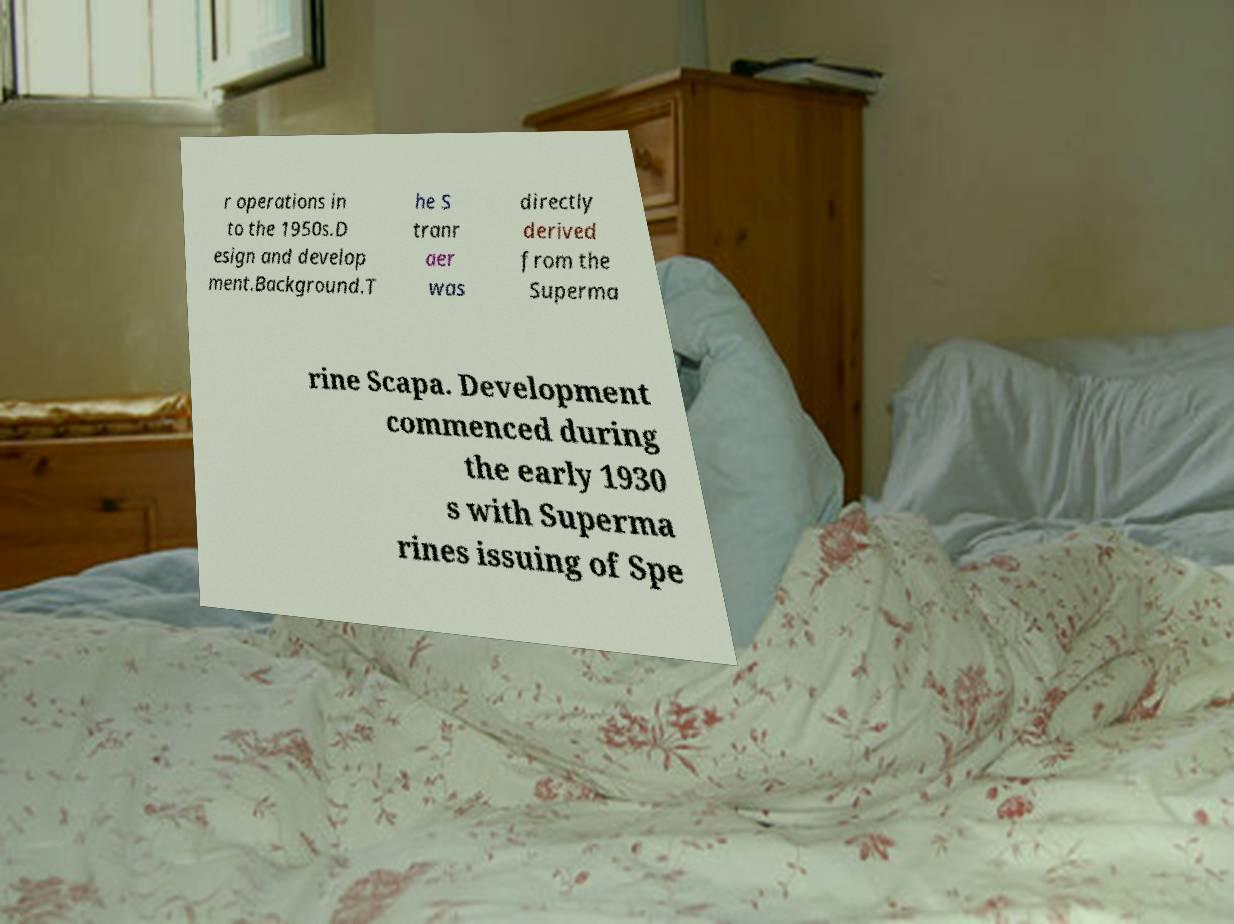Please identify and transcribe the text found in this image. r operations in to the 1950s.D esign and develop ment.Background.T he S tranr aer was directly derived from the Superma rine Scapa. Development commenced during the early 1930 s with Superma rines issuing of Spe 